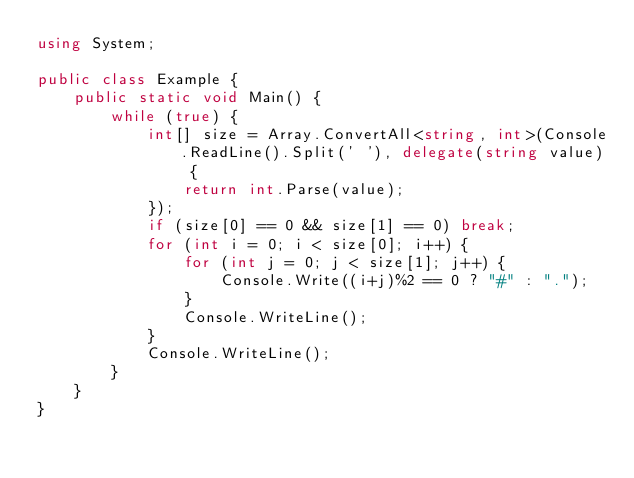Convert code to text. <code><loc_0><loc_0><loc_500><loc_500><_C#_>using System;

public class Example {
    public static void Main() {
        while (true) {
            int[] size = Array.ConvertAll<string, int>(Console.ReadLine().Split(' '), delegate(string value) {
                return int.Parse(value);
            });
            if (size[0] == 0 && size[1] == 0) break;
            for (int i = 0; i < size[0]; i++) {
                for (int j = 0; j < size[1]; j++) {
                    Console.Write((i+j)%2 == 0 ? "#" : ".");
                }
                Console.WriteLine();
            }
            Console.WriteLine();
        }
    }
}</code> 